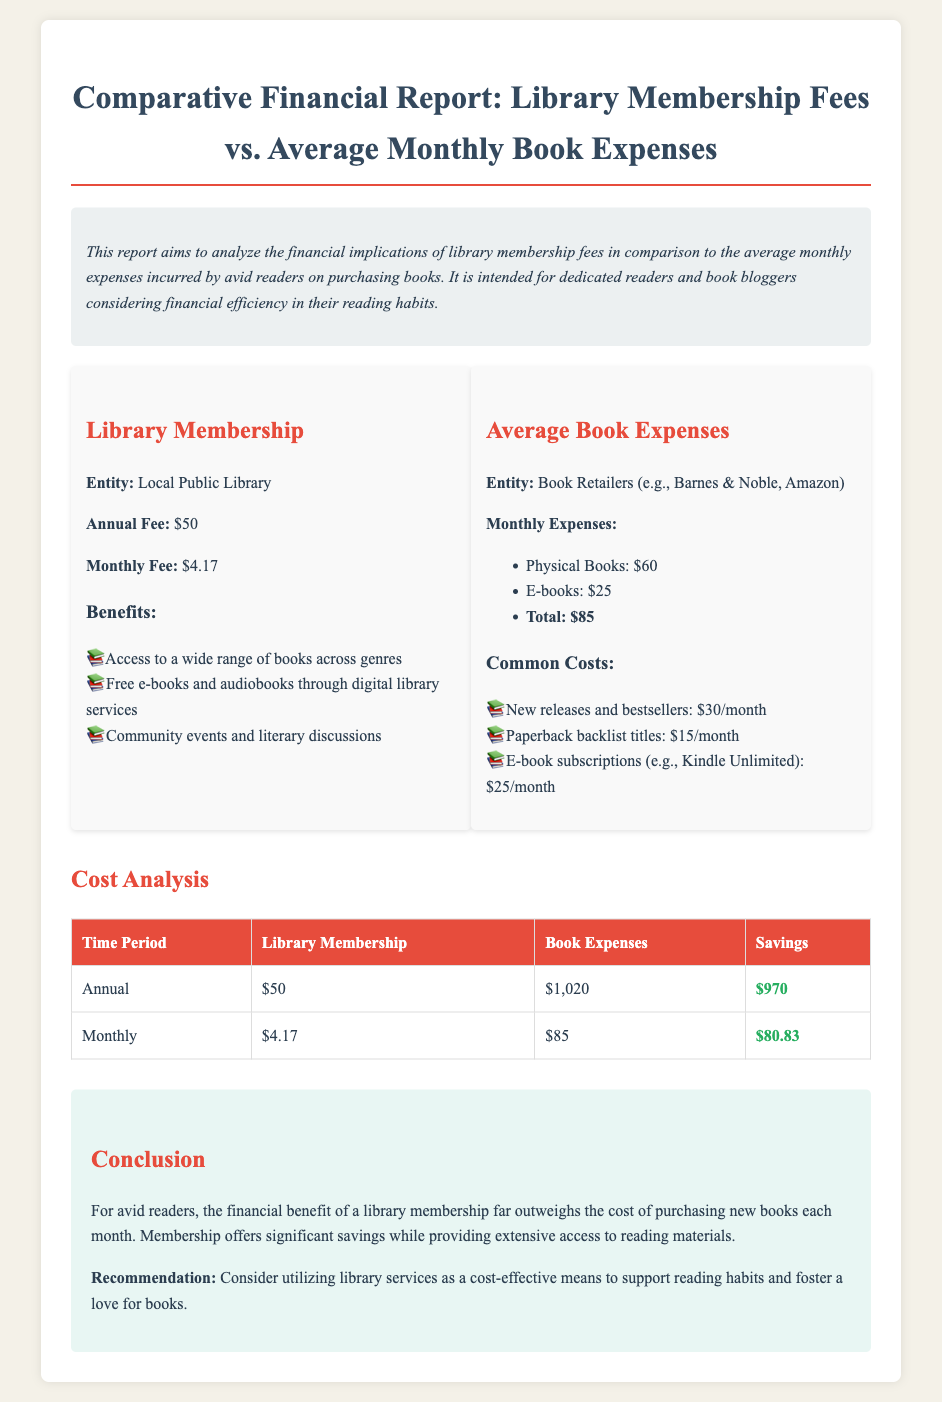What is the annual fee for the library membership? The document states the annual fee for the library membership is $50.
Answer: $50 What is the total average monthly cost of buying books? The total monthly expenses on books is calculated as $60 for physical books plus $25 for e-books, totaling $85.
Answer: $85 How much can one save annually by opting for a library membership? The savings per year is the difference between book expenses and library membership, which is $1,020 - $50 = $970.
Answer: $970 What are the two categories of book expenses mentioned? The document lists physical books and e-books as the two types of book expenses.
Answer: Physical books, e-books What is the monthly fee for the library membership? The document provides the monthly fee for the library membership as $4.17.
Answer: $4.17 How much do new releases and bestsellers cost on average per month? According to the report, new releases and bestsellers cost $30 each month.
Answer: $30 What is the main conclusion regarding the financial benefit of library membership? The conclusion states that the financial benefit of library membership exceeds the cost of purchasing new books each month.
Answer: Exceeds the cost What is the organization providing library membership? The document mentions the entity offering the membership as the Local Public Library.
Answer: Local Public Library 